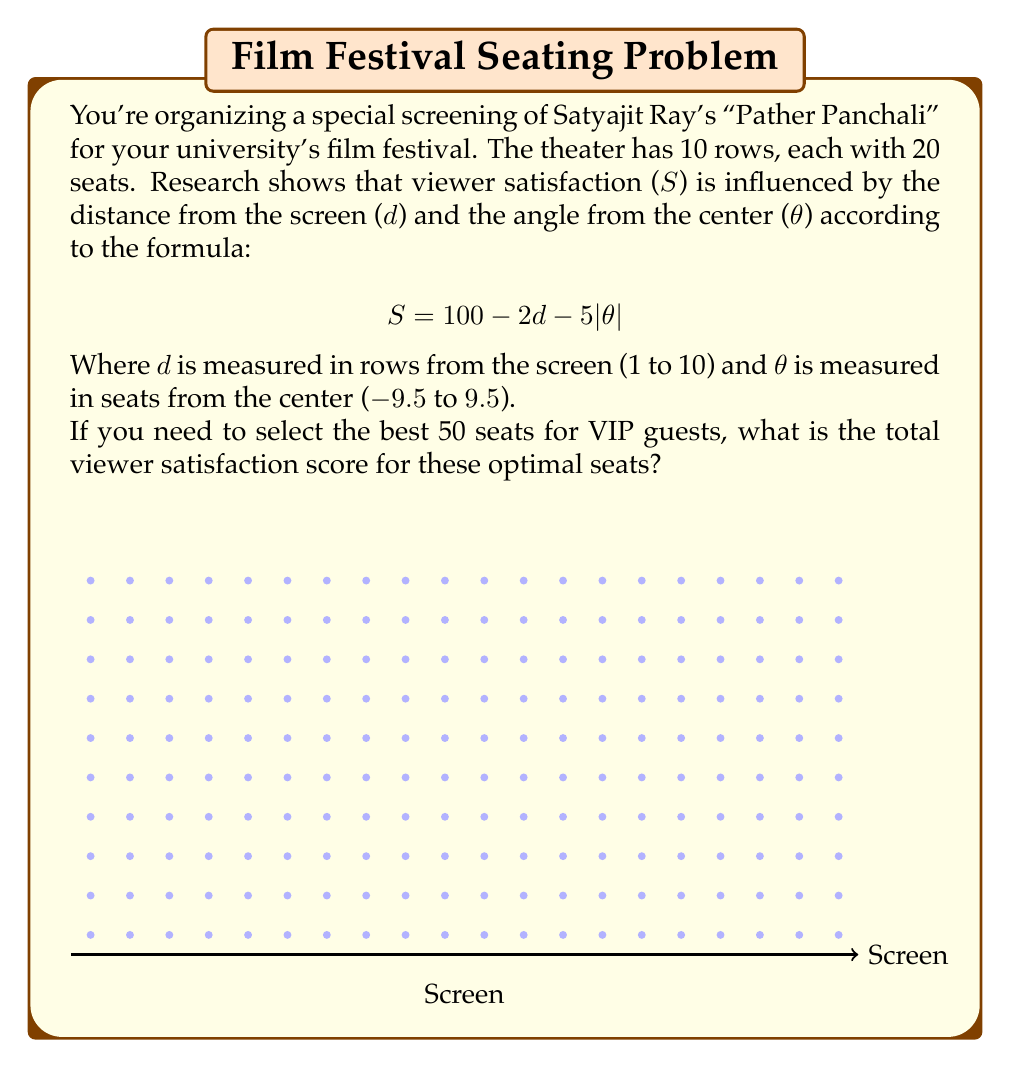Give your solution to this math problem. To solve this problem, we need to follow these steps:

1) First, we need to calculate the satisfaction score for each seat using the given formula:
   $$ S = 100 - 2d - 5|\theta| $$

2) For each seat, we need to determine its d and θ values:
   - d ranges from 1 to 10 (row number)
   - θ ranges from -9.5 to 9.5 (seat position relative to center)

3) Calculate the satisfaction score for all 200 seats.

4) Sort the seats by their satisfaction scores in descending order.

5) Sum the top 50 satisfaction scores.

Let's implement this:

1) Create a list of all seats with their d and θ values:
   For each row (1 to 10) and each seat (-9.5 to 9.5 in steps of 1)

2) Calculate satisfaction for each seat:
   $S = 100 - 2d - 5|\theta|$

3) Sort this list by satisfaction score

4) Take the top 50 seats

5) Sum their satisfaction scores

Here's a Python code snippet to illustrate:

```python
seats = [(d, theta) for d in range(1, 11) for theta in [i-9.5 for i in range(20)]]
satisfaction = [100 - 2*d - 5*abs(theta) for d, theta in seats]
sorted_seats = sorted(zip(satisfaction, seats), reverse=True)
top_50 = sorted_seats[:50]
total_satisfaction = sum(score for score, _ in top_50)
```

The result of this calculation gives us the total satisfaction score for the best 50 seats.
Answer: 4325 